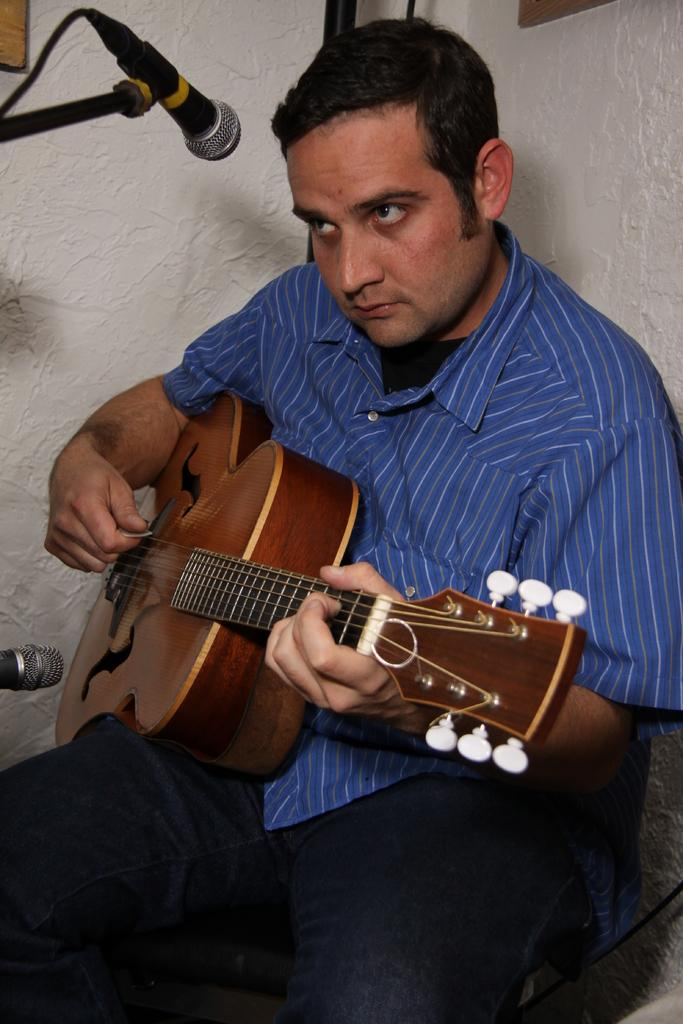What is the man in the image doing? The man is playing a guitar. What object is the man using to amplify his voice? The man is in front of a microphone. What can be seen behind the man in the image? There is a wall in the background of the image. What type of ornament is hanging from the guitar in the image? There is no ornament hanging from the guitar in the image. Can you see a donkey in the background of the image? There is no donkey present in the image. 